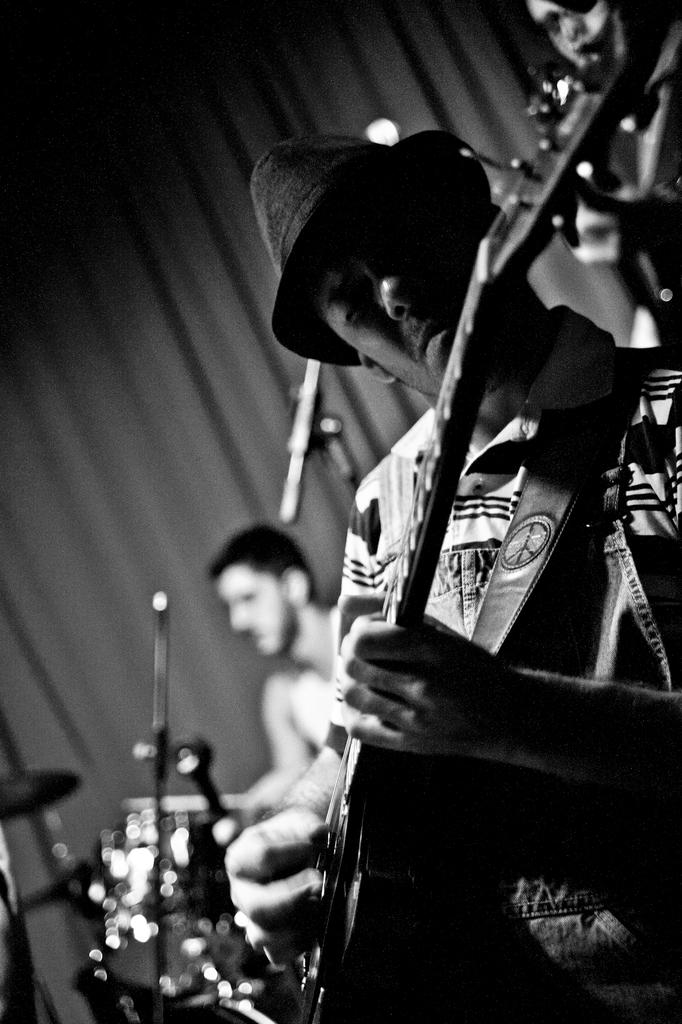How many people are in the image? There are multiple people in the image. What are the people doing in the image? The people are playing musical instruments. Can you describe the musical instruments being played? The musical instruments are different from each other. Where is the kitten sleeping in the image? There is no kitten present in the image. What type of tent can be seen in the background of the image? There is no tent present in the image. 